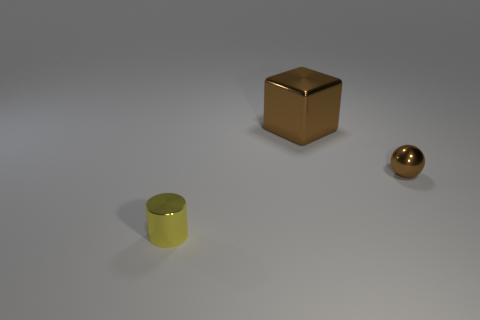Do the object in front of the ball and the shiny cube have the same size?
Keep it short and to the point. No. There is a metal object that is behind the yellow cylinder and in front of the brown block; what is its shape?
Make the answer very short. Sphere. Are there any tiny brown spheres in front of the brown metal ball?
Make the answer very short. No. Are there any other things that have the same shape as the small brown shiny thing?
Give a very brief answer. No. Is the small yellow metallic object the same shape as the large object?
Your answer should be compact. No. Is the number of small brown metallic spheres on the left side of the big cube the same as the number of small metallic objects behind the cylinder?
Provide a succinct answer. No. How many other objects are the same material as the small cylinder?
Provide a succinct answer. 2. How many large objects are either brown metallic objects or brown cubes?
Give a very brief answer. 1. Is the number of large objects that are left of the brown shiny sphere the same as the number of metal blocks?
Provide a succinct answer. Yes. Are there any brown spheres behind the brown thing that is right of the large brown cube?
Provide a short and direct response. No. 